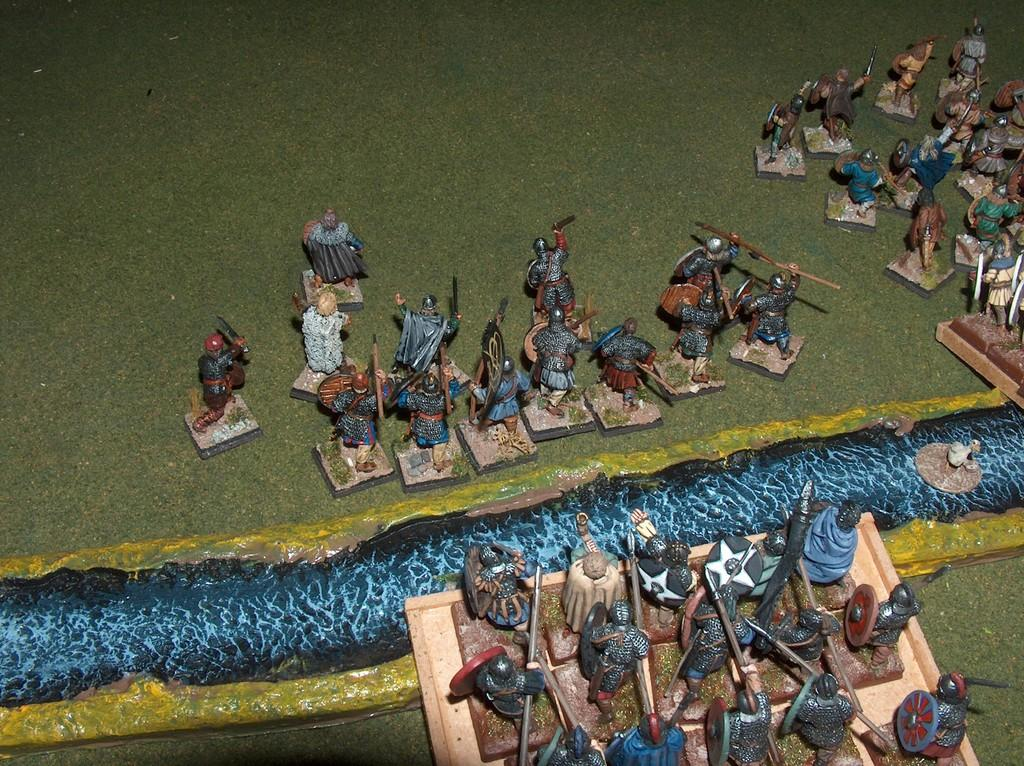What objects can be seen in the image? There are toys in the image. What type of surface is visible in the background of the image? There is a floor visible in the background of the image. What type of silver material is present in the image? There is no silver material present in the image. Can you see a kitty playing with the toys in the image? There is no kitty present in the image. 